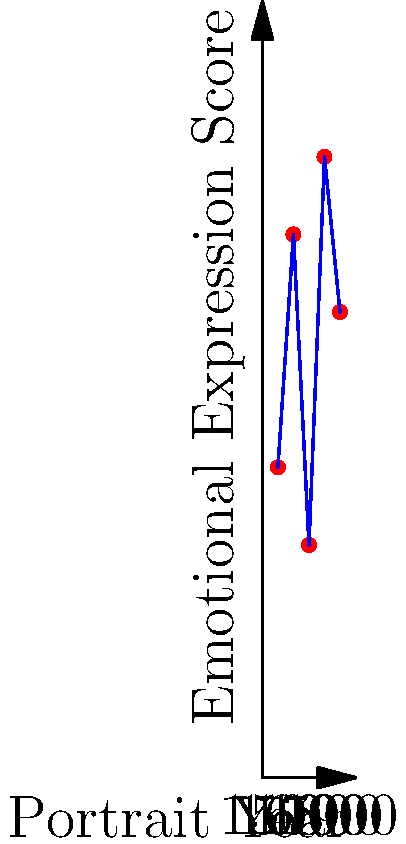The graph shows the emotional expression scores of royal portraits across different centuries. What psychological insight can be drawn from the fluctuation in emotional expression, particularly the sharp decline in the 1700s? To analyze this graph and draw psychological insights, we need to follow these steps:

1. Observe the overall trend:
   The emotional expression scores fluctuate over the centuries, showing variability in how royals were portrayed.

2. Identify key points:
   - 1500: Score of 20
   - 1600: Increase to 35
   - 1700: Sharp decline to 15
   - 1800: Significant rise to 40
   - 1900: Slight decrease to 30

3. Focus on the 1700s decline:
   The sharp drop from 35 to 15 between 1600 and 1700 is the most dramatic change in the graph.

4. Consider historical context:
   The 1700s saw the Age of Enlightenment, which emphasized reason and individualism over tradition.

5. Analyze psychological implications:
   - The low score in the 1700s might indicate a shift towards more restrained, stoic expressions in royal portraits.
   - This could reflect a desire to appear more rational and composed, in line with Enlightenment ideals.
   - It may also suggest a psychological distancing from emotional display, possibly to maintain an image of control and authority.

6. Compare with surrounding centuries:
   - The higher scores in the 1600s and 1800s suggest more emotionally expressive portraits, possibly reflecting different cultural values or expectations of royalty in those periods.

7. Draw a conclusion:
   The sharp decline in emotional expression during the 1700s likely reflects the influence of Enlightenment philosophy on royal self-presentation, emphasizing reason and restraint over emotional display.
Answer: Enlightenment-era emphasis on reason and restraint in royal self-presentation 